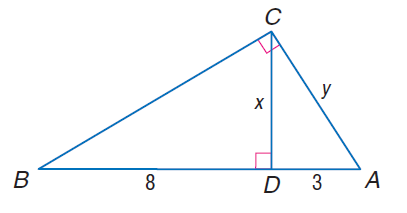Question: Find y.
Choices:
A. \sqrt { 29 }
B. \sqrt { 31 }
C. \sqrt { 33 }
D. \sqrt { 35 }
Answer with the letter. Answer: C Question: Find x.
Choices:
A. 2 \sqrt { 3 }
B. 2 \sqrt { 6 }
C. 4 \sqrt { 3 }
D. 4 \sqrt { 6 }
Answer with the letter. Answer: B 